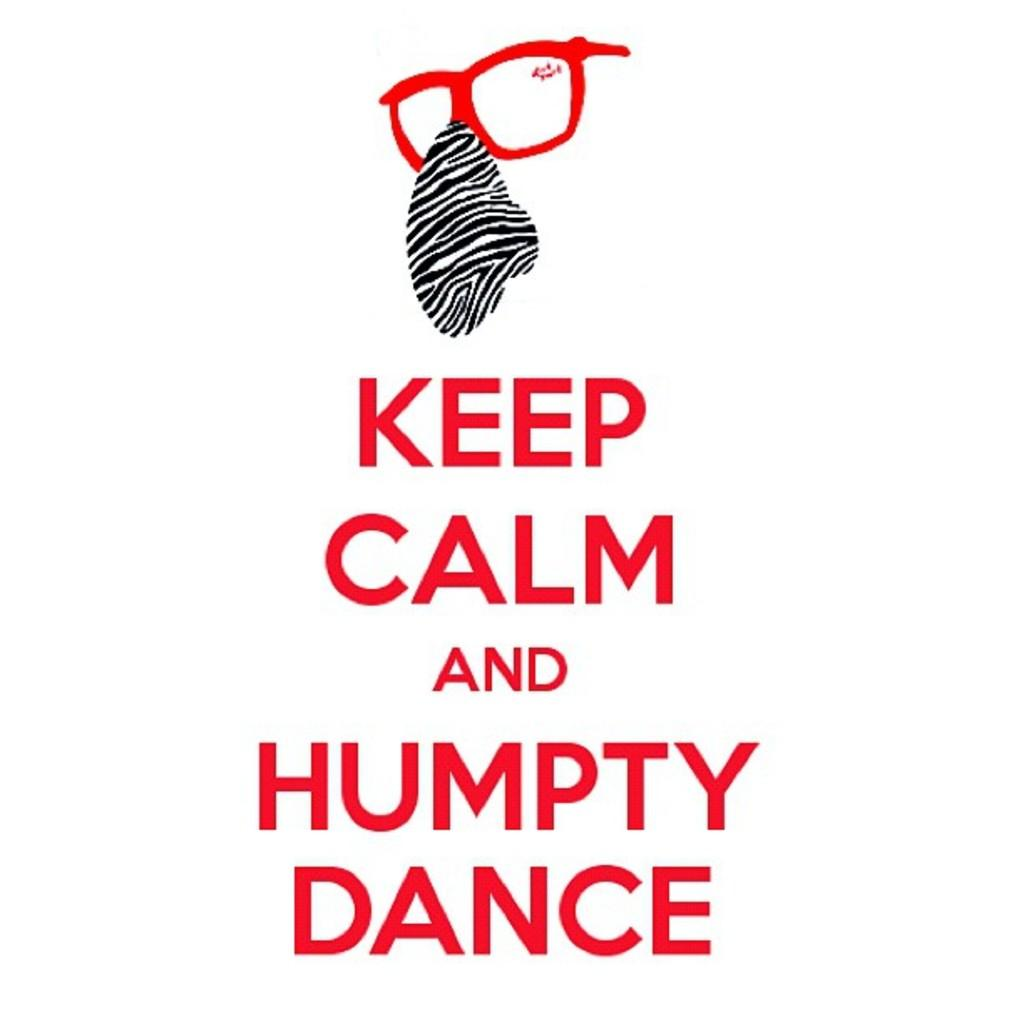What message is conveyed in the text in the image? The text in the image says "KEEP CALM AND HUMPTY DANCE". What color is the text in the image? The text is in red color. What type of paper is the locket made of in the image? There is no locket present in the image. 